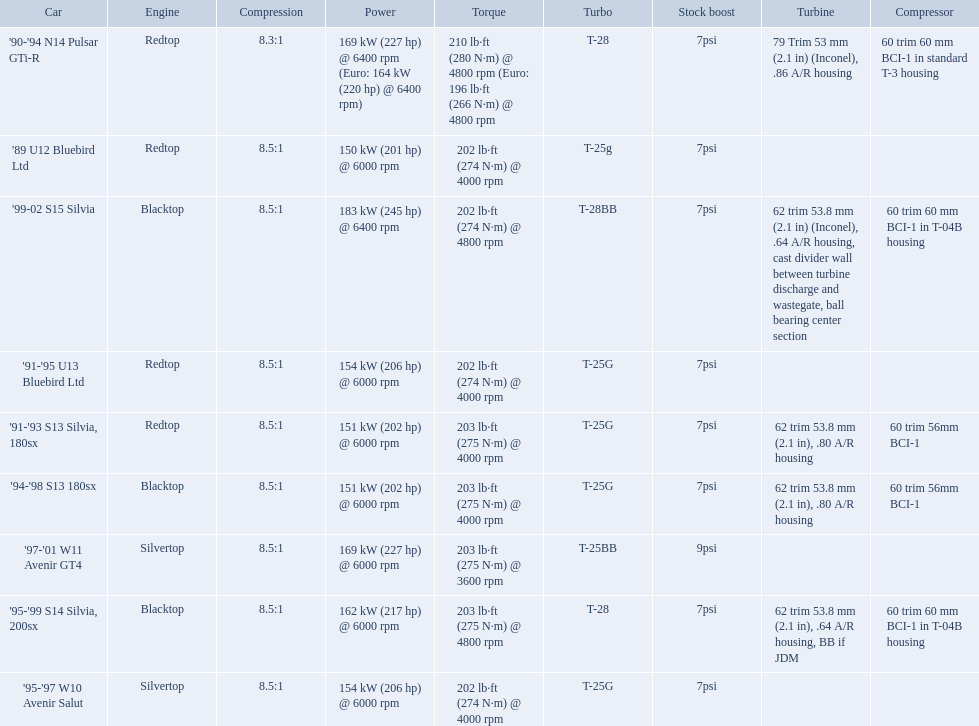What are the psi's? 7psi, 7psi, 7psi, 9psi, 7psi, 7psi, 7psi, 7psi, 7psi. What are the number(s) greater than 7? 9psi. Which car has that number? '97-'01 W11 Avenir GT4. What cars are there? '89 U12 Bluebird Ltd, 7psi, '91-'95 U13 Bluebird Ltd, 7psi, '95-'97 W10 Avenir Salut, 7psi, '97-'01 W11 Avenir GT4, 9psi, '90-'94 N14 Pulsar GTi-R, 7psi, '91-'93 S13 Silvia, 180sx, 7psi, '94-'98 S13 180sx, 7psi, '95-'99 S14 Silvia, 200sx, 7psi, '99-02 S15 Silvia, 7psi. Which stock boost is over 7psi? '97-'01 W11 Avenir GT4, 9psi. What car is it? '97-'01 W11 Avenir GT4. Which cars featured blacktop engines? '94-'98 S13 180sx, '95-'99 S14 Silvia, 200sx, '99-02 S15 Silvia. Which of these had t-04b compressor housings? '95-'99 S14 Silvia, 200sx, '99-02 S15 Silvia. Which one of these has the highest horsepower? '99-02 S15 Silvia. What are all of the nissan cars? '89 U12 Bluebird Ltd, '91-'95 U13 Bluebird Ltd, '95-'97 W10 Avenir Salut, '97-'01 W11 Avenir GT4, '90-'94 N14 Pulsar GTi-R, '91-'93 S13 Silvia, 180sx, '94-'98 S13 180sx, '95-'99 S14 Silvia, 200sx, '99-02 S15 Silvia. Of these cars, which one is a '90-'94 n14 pulsar gti-r? '90-'94 N14 Pulsar GTi-R. What is the compression of this car? 8.3:1. What are all the cars? '89 U12 Bluebird Ltd, '91-'95 U13 Bluebird Ltd, '95-'97 W10 Avenir Salut, '97-'01 W11 Avenir GT4, '90-'94 N14 Pulsar GTi-R, '91-'93 S13 Silvia, 180sx, '94-'98 S13 180sx, '95-'99 S14 Silvia, 200sx, '99-02 S15 Silvia. What are their stock boosts? 7psi, 7psi, 7psi, 9psi, 7psi, 7psi, 7psi, 7psi, 7psi. And which car has the highest stock boost? '97-'01 W11 Avenir GT4. 